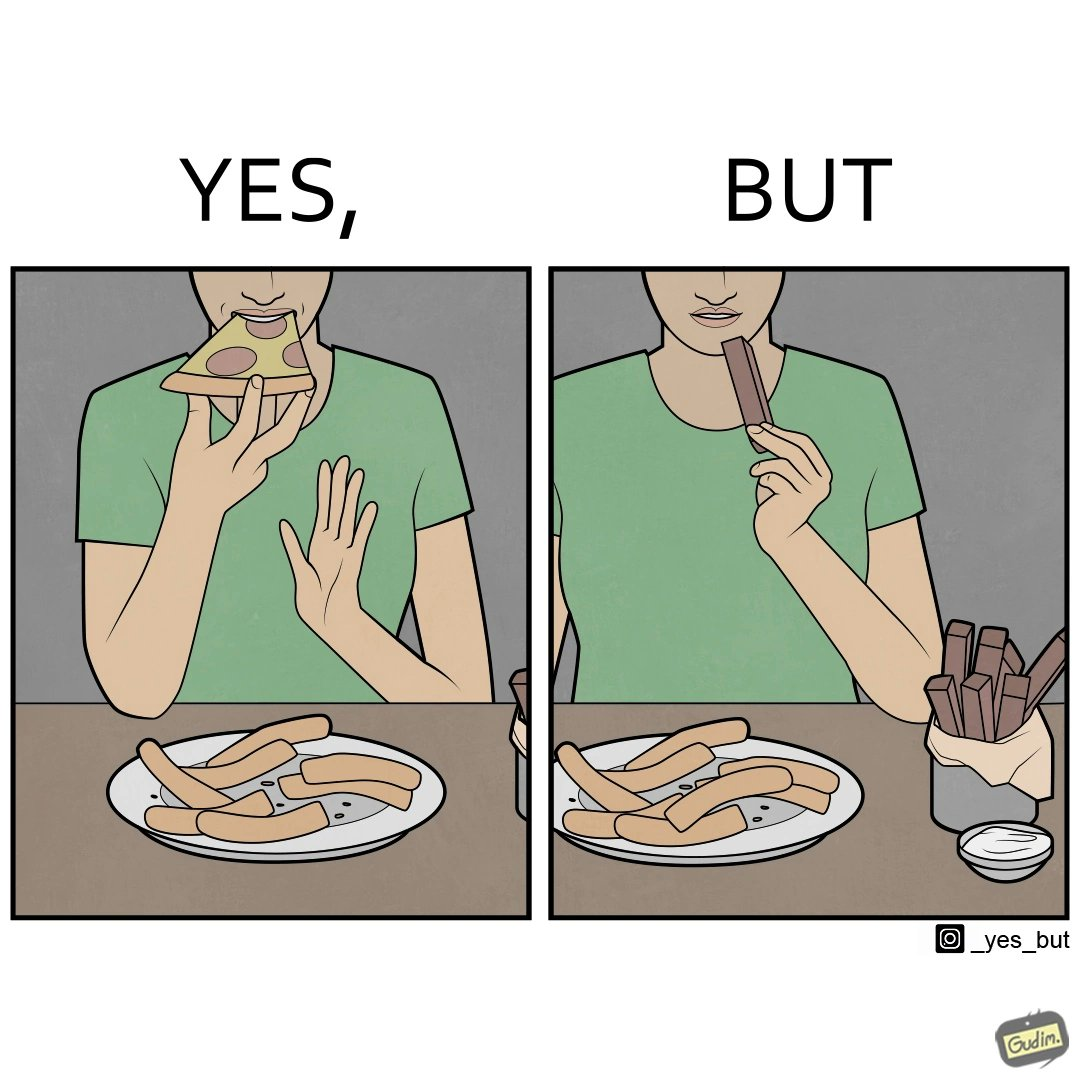Describe what you see in the left and right parts of this image. In the left part of the image: a person eating pizza and leaving the crusts on the table In the right part of the image: person eating chocolate bars 